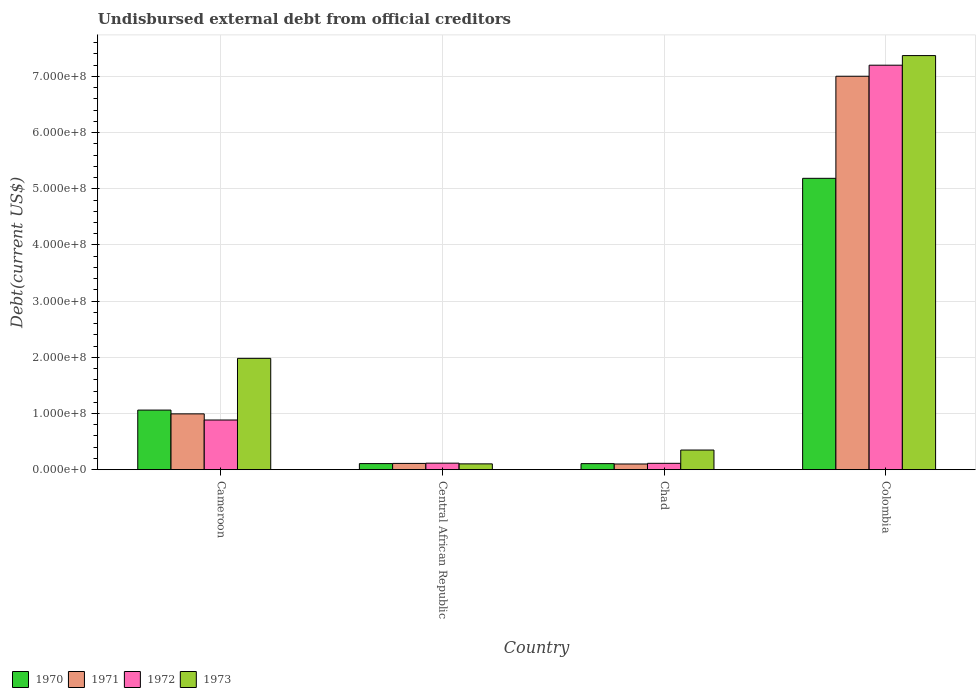How many groups of bars are there?
Your response must be concise. 4. Are the number of bars on each tick of the X-axis equal?
Offer a terse response. Yes. What is the label of the 2nd group of bars from the left?
Ensure brevity in your answer.  Central African Republic. In how many cases, is the number of bars for a given country not equal to the number of legend labels?
Provide a short and direct response. 0. What is the total debt in 1973 in Chad?
Ensure brevity in your answer.  3.50e+07. Across all countries, what is the maximum total debt in 1971?
Ensure brevity in your answer.  7.00e+08. Across all countries, what is the minimum total debt in 1973?
Make the answer very short. 1.04e+07. In which country was the total debt in 1970 maximum?
Make the answer very short. Colombia. In which country was the total debt in 1971 minimum?
Provide a succinct answer. Chad. What is the total total debt in 1970 in the graph?
Your answer should be very brief. 6.46e+08. What is the difference between the total debt in 1970 in Cameroon and that in Colombia?
Make the answer very short. -4.12e+08. What is the difference between the total debt in 1973 in Central African Republic and the total debt in 1972 in Cameroon?
Your answer should be compact. -7.81e+07. What is the average total debt in 1973 per country?
Make the answer very short. 2.45e+08. What is the difference between the total debt of/in 1972 and total debt of/in 1973 in Central African Republic?
Offer a terse response. 1.27e+06. In how many countries, is the total debt in 1972 greater than 360000000 US$?
Offer a terse response. 1. What is the ratio of the total debt in 1972 in Central African Republic to that in Colombia?
Give a very brief answer. 0.02. What is the difference between the highest and the second highest total debt in 1973?
Make the answer very short. 5.39e+08. What is the difference between the highest and the lowest total debt in 1973?
Ensure brevity in your answer.  7.27e+08. Is the sum of the total debt in 1973 in Chad and Colombia greater than the maximum total debt in 1970 across all countries?
Keep it short and to the point. Yes. What does the 3rd bar from the left in Central African Republic represents?
Make the answer very short. 1972. What does the 4th bar from the right in Cameroon represents?
Provide a short and direct response. 1970. Are all the bars in the graph horizontal?
Provide a succinct answer. No. Does the graph contain any zero values?
Provide a short and direct response. No. Does the graph contain grids?
Offer a terse response. Yes. Where does the legend appear in the graph?
Provide a succinct answer. Bottom left. What is the title of the graph?
Keep it short and to the point. Undisbursed external debt from official creditors. What is the label or title of the X-axis?
Make the answer very short. Country. What is the label or title of the Y-axis?
Your answer should be very brief. Debt(current US$). What is the Debt(current US$) in 1970 in Cameroon?
Provide a short and direct response. 1.06e+08. What is the Debt(current US$) in 1971 in Cameroon?
Your answer should be compact. 9.94e+07. What is the Debt(current US$) in 1972 in Cameroon?
Provide a short and direct response. 8.84e+07. What is the Debt(current US$) in 1973 in Cameroon?
Provide a succinct answer. 1.98e+08. What is the Debt(current US$) in 1970 in Central African Republic?
Offer a very short reply. 1.08e+07. What is the Debt(current US$) of 1971 in Central African Republic?
Your answer should be compact. 1.12e+07. What is the Debt(current US$) in 1972 in Central African Republic?
Offer a very short reply. 1.16e+07. What is the Debt(current US$) in 1973 in Central African Republic?
Offer a very short reply. 1.04e+07. What is the Debt(current US$) in 1970 in Chad?
Your response must be concise. 1.08e+07. What is the Debt(current US$) in 1971 in Chad?
Offer a terse response. 1.02e+07. What is the Debt(current US$) in 1972 in Chad?
Make the answer very short. 1.14e+07. What is the Debt(current US$) of 1973 in Chad?
Your answer should be compact. 3.50e+07. What is the Debt(current US$) in 1970 in Colombia?
Provide a succinct answer. 5.19e+08. What is the Debt(current US$) in 1971 in Colombia?
Your answer should be very brief. 7.00e+08. What is the Debt(current US$) in 1972 in Colombia?
Ensure brevity in your answer.  7.20e+08. What is the Debt(current US$) of 1973 in Colombia?
Provide a short and direct response. 7.37e+08. Across all countries, what is the maximum Debt(current US$) in 1970?
Provide a succinct answer. 5.19e+08. Across all countries, what is the maximum Debt(current US$) in 1971?
Provide a short and direct response. 7.00e+08. Across all countries, what is the maximum Debt(current US$) of 1972?
Your response must be concise. 7.20e+08. Across all countries, what is the maximum Debt(current US$) of 1973?
Keep it short and to the point. 7.37e+08. Across all countries, what is the minimum Debt(current US$) of 1970?
Make the answer very short. 1.08e+07. Across all countries, what is the minimum Debt(current US$) of 1971?
Offer a terse response. 1.02e+07. Across all countries, what is the minimum Debt(current US$) in 1972?
Ensure brevity in your answer.  1.14e+07. Across all countries, what is the minimum Debt(current US$) of 1973?
Provide a short and direct response. 1.04e+07. What is the total Debt(current US$) in 1970 in the graph?
Make the answer very short. 6.46e+08. What is the total Debt(current US$) of 1971 in the graph?
Make the answer very short. 8.21e+08. What is the total Debt(current US$) of 1972 in the graph?
Give a very brief answer. 8.31e+08. What is the total Debt(current US$) in 1973 in the graph?
Offer a very short reply. 9.81e+08. What is the difference between the Debt(current US$) of 1970 in Cameroon and that in Central African Republic?
Your response must be concise. 9.52e+07. What is the difference between the Debt(current US$) in 1971 in Cameroon and that in Central African Republic?
Ensure brevity in your answer.  8.82e+07. What is the difference between the Debt(current US$) in 1972 in Cameroon and that in Central African Republic?
Offer a very short reply. 7.68e+07. What is the difference between the Debt(current US$) in 1973 in Cameroon and that in Central African Republic?
Offer a very short reply. 1.88e+08. What is the difference between the Debt(current US$) in 1970 in Cameroon and that in Chad?
Your answer should be compact. 9.53e+07. What is the difference between the Debt(current US$) of 1971 in Cameroon and that in Chad?
Your answer should be very brief. 8.92e+07. What is the difference between the Debt(current US$) in 1972 in Cameroon and that in Chad?
Offer a very short reply. 7.71e+07. What is the difference between the Debt(current US$) of 1973 in Cameroon and that in Chad?
Offer a very short reply. 1.63e+08. What is the difference between the Debt(current US$) in 1970 in Cameroon and that in Colombia?
Make the answer very short. -4.12e+08. What is the difference between the Debt(current US$) of 1971 in Cameroon and that in Colombia?
Your answer should be very brief. -6.01e+08. What is the difference between the Debt(current US$) of 1972 in Cameroon and that in Colombia?
Provide a succinct answer. -6.31e+08. What is the difference between the Debt(current US$) of 1973 in Cameroon and that in Colombia?
Make the answer very short. -5.39e+08. What is the difference between the Debt(current US$) in 1970 in Central African Republic and that in Chad?
Provide a succinct answer. 5.50e+04. What is the difference between the Debt(current US$) in 1971 in Central African Republic and that in Chad?
Keep it short and to the point. 1.04e+06. What is the difference between the Debt(current US$) in 1972 in Central African Republic and that in Chad?
Offer a very short reply. 2.79e+05. What is the difference between the Debt(current US$) in 1973 in Central African Republic and that in Chad?
Keep it short and to the point. -2.46e+07. What is the difference between the Debt(current US$) in 1970 in Central African Republic and that in Colombia?
Give a very brief answer. -5.08e+08. What is the difference between the Debt(current US$) of 1971 in Central African Republic and that in Colombia?
Offer a terse response. -6.89e+08. What is the difference between the Debt(current US$) of 1972 in Central African Republic and that in Colombia?
Your answer should be compact. -7.08e+08. What is the difference between the Debt(current US$) in 1973 in Central African Republic and that in Colombia?
Your response must be concise. -7.27e+08. What is the difference between the Debt(current US$) of 1970 in Chad and that in Colombia?
Ensure brevity in your answer.  -5.08e+08. What is the difference between the Debt(current US$) of 1971 in Chad and that in Colombia?
Your answer should be compact. -6.90e+08. What is the difference between the Debt(current US$) in 1972 in Chad and that in Colombia?
Provide a succinct answer. -7.09e+08. What is the difference between the Debt(current US$) of 1973 in Chad and that in Colombia?
Make the answer very short. -7.02e+08. What is the difference between the Debt(current US$) of 1970 in Cameroon and the Debt(current US$) of 1971 in Central African Republic?
Keep it short and to the point. 9.49e+07. What is the difference between the Debt(current US$) of 1970 in Cameroon and the Debt(current US$) of 1972 in Central African Republic?
Ensure brevity in your answer.  9.45e+07. What is the difference between the Debt(current US$) in 1970 in Cameroon and the Debt(current US$) in 1973 in Central African Republic?
Provide a short and direct response. 9.57e+07. What is the difference between the Debt(current US$) of 1971 in Cameroon and the Debt(current US$) of 1972 in Central African Republic?
Your response must be concise. 8.77e+07. What is the difference between the Debt(current US$) of 1971 in Cameroon and the Debt(current US$) of 1973 in Central African Republic?
Make the answer very short. 8.90e+07. What is the difference between the Debt(current US$) in 1972 in Cameroon and the Debt(current US$) in 1973 in Central African Republic?
Provide a short and direct response. 7.81e+07. What is the difference between the Debt(current US$) of 1970 in Cameroon and the Debt(current US$) of 1971 in Chad?
Offer a very short reply. 9.59e+07. What is the difference between the Debt(current US$) of 1970 in Cameroon and the Debt(current US$) of 1972 in Chad?
Ensure brevity in your answer.  9.47e+07. What is the difference between the Debt(current US$) of 1970 in Cameroon and the Debt(current US$) of 1973 in Chad?
Offer a terse response. 7.11e+07. What is the difference between the Debt(current US$) in 1971 in Cameroon and the Debt(current US$) in 1972 in Chad?
Keep it short and to the point. 8.80e+07. What is the difference between the Debt(current US$) of 1971 in Cameroon and the Debt(current US$) of 1973 in Chad?
Make the answer very short. 6.44e+07. What is the difference between the Debt(current US$) of 1972 in Cameroon and the Debt(current US$) of 1973 in Chad?
Your answer should be very brief. 5.35e+07. What is the difference between the Debt(current US$) in 1970 in Cameroon and the Debt(current US$) in 1971 in Colombia?
Keep it short and to the point. -5.94e+08. What is the difference between the Debt(current US$) of 1970 in Cameroon and the Debt(current US$) of 1972 in Colombia?
Your answer should be very brief. -6.14e+08. What is the difference between the Debt(current US$) in 1970 in Cameroon and the Debt(current US$) in 1973 in Colombia?
Your response must be concise. -6.31e+08. What is the difference between the Debt(current US$) of 1971 in Cameroon and the Debt(current US$) of 1972 in Colombia?
Keep it short and to the point. -6.21e+08. What is the difference between the Debt(current US$) in 1971 in Cameroon and the Debt(current US$) in 1973 in Colombia?
Keep it short and to the point. -6.38e+08. What is the difference between the Debt(current US$) of 1972 in Cameroon and the Debt(current US$) of 1973 in Colombia?
Provide a short and direct response. -6.49e+08. What is the difference between the Debt(current US$) of 1970 in Central African Republic and the Debt(current US$) of 1971 in Chad?
Make the answer very short. 6.94e+05. What is the difference between the Debt(current US$) in 1970 in Central African Republic and the Debt(current US$) in 1972 in Chad?
Offer a terse response. -5.09e+05. What is the difference between the Debt(current US$) of 1970 in Central African Republic and the Debt(current US$) of 1973 in Chad?
Provide a short and direct response. -2.41e+07. What is the difference between the Debt(current US$) of 1971 in Central African Republic and the Debt(current US$) of 1972 in Chad?
Give a very brief answer. -1.65e+05. What is the difference between the Debt(current US$) in 1971 in Central African Republic and the Debt(current US$) in 1973 in Chad?
Your response must be concise. -2.38e+07. What is the difference between the Debt(current US$) in 1972 in Central African Republic and the Debt(current US$) in 1973 in Chad?
Your answer should be very brief. -2.34e+07. What is the difference between the Debt(current US$) of 1970 in Central African Republic and the Debt(current US$) of 1971 in Colombia?
Provide a short and direct response. -6.89e+08. What is the difference between the Debt(current US$) in 1970 in Central African Republic and the Debt(current US$) in 1972 in Colombia?
Offer a terse response. -7.09e+08. What is the difference between the Debt(current US$) in 1970 in Central African Republic and the Debt(current US$) in 1973 in Colombia?
Offer a very short reply. -7.26e+08. What is the difference between the Debt(current US$) in 1971 in Central African Republic and the Debt(current US$) in 1972 in Colombia?
Your response must be concise. -7.09e+08. What is the difference between the Debt(current US$) in 1971 in Central African Republic and the Debt(current US$) in 1973 in Colombia?
Give a very brief answer. -7.26e+08. What is the difference between the Debt(current US$) in 1972 in Central African Republic and the Debt(current US$) in 1973 in Colombia?
Provide a succinct answer. -7.25e+08. What is the difference between the Debt(current US$) in 1970 in Chad and the Debt(current US$) in 1971 in Colombia?
Your answer should be very brief. -6.89e+08. What is the difference between the Debt(current US$) of 1970 in Chad and the Debt(current US$) of 1972 in Colombia?
Make the answer very short. -7.09e+08. What is the difference between the Debt(current US$) in 1970 in Chad and the Debt(current US$) in 1973 in Colombia?
Offer a terse response. -7.26e+08. What is the difference between the Debt(current US$) of 1971 in Chad and the Debt(current US$) of 1972 in Colombia?
Provide a short and direct response. -7.10e+08. What is the difference between the Debt(current US$) of 1971 in Chad and the Debt(current US$) of 1973 in Colombia?
Offer a terse response. -7.27e+08. What is the difference between the Debt(current US$) of 1972 in Chad and the Debt(current US$) of 1973 in Colombia?
Provide a succinct answer. -7.26e+08. What is the average Debt(current US$) of 1970 per country?
Provide a succinct answer. 1.62e+08. What is the average Debt(current US$) in 1971 per country?
Ensure brevity in your answer.  2.05e+08. What is the average Debt(current US$) in 1972 per country?
Ensure brevity in your answer.  2.08e+08. What is the average Debt(current US$) in 1973 per country?
Your answer should be compact. 2.45e+08. What is the difference between the Debt(current US$) of 1970 and Debt(current US$) of 1971 in Cameroon?
Give a very brief answer. 6.72e+06. What is the difference between the Debt(current US$) of 1970 and Debt(current US$) of 1972 in Cameroon?
Offer a very short reply. 1.76e+07. What is the difference between the Debt(current US$) in 1970 and Debt(current US$) in 1973 in Cameroon?
Provide a short and direct response. -9.21e+07. What is the difference between the Debt(current US$) in 1971 and Debt(current US$) in 1972 in Cameroon?
Offer a very short reply. 1.09e+07. What is the difference between the Debt(current US$) in 1971 and Debt(current US$) in 1973 in Cameroon?
Provide a short and direct response. -9.88e+07. What is the difference between the Debt(current US$) in 1972 and Debt(current US$) in 1973 in Cameroon?
Make the answer very short. -1.10e+08. What is the difference between the Debt(current US$) of 1970 and Debt(current US$) of 1971 in Central African Republic?
Offer a terse response. -3.44e+05. What is the difference between the Debt(current US$) in 1970 and Debt(current US$) in 1972 in Central African Republic?
Offer a very short reply. -7.88e+05. What is the difference between the Debt(current US$) in 1970 and Debt(current US$) in 1973 in Central African Republic?
Give a very brief answer. 4.80e+05. What is the difference between the Debt(current US$) of 1971 and Debt(current US$) of 1972 in Central African Republic?
Offer a terse response. -4.44e+05. What is the difference between the Debt(current US$) in 1971 and Debt(current US$) in 1973 in Central African Republic?
Your response must be concise. 8.24e+05. What is the difference between the Debt(current US$) in 1972 and Debt(current US$) in 1973 in Central African Republic?
Keep it short and to the point. 1.27e+06. What is the difference between the Debt(current US$) in 1970 and Debt(current US$) in 1971 in Chad?
Ensure brevity in your answer.  6.39e+05. What is the difference between the Debt(current US$) in 1970 and Debt(current US$) in 1972 in Chad?
Offer a terse response. -5.64e+05. What is the difference between the Debt(current US$) in 1970 and Debt(current US$) in 1973 in Chad?
Offer a very short reply. -2.42e+07. What is the difference between the Debt(current US$) of 1971 and Debt(current US$) of 1972 in Chad?
Make the answer very short. -1.20e+06. What is the difference between the Debt(current US$) of 1971 and Debt(current US$) of 1973 in Chad?
Offer a terse response. -2.48e+07. What is the difference between the Debt(current US$) in 1972 and Debt(current US$) in 1973 in Chad?
Your response must be concise. -2.36e+07. What is the difference between the Debt(current US$) in 1970 and Debt(current US$) in 1971 in Colombia?
Provide a short and direct response. -1.82e+08. What is the difference between the Debt(current US$) of 1970 and Debt(current US$) of 1972 in Colombia?
Offer a very short reply. -2.01e+08. What is the difference between the Debt(current US$) in 1970 and Debt(current US$) in 1973 in Colombia?
Make the answer very short. -2.18e+08. What is the difference between the Debt(current US$) of 1971 and Debt(current US$) of 1972 in Colombia?
Your answer should be very brief. -1.97e+07. What is the difference between the Debt(current US$) of 1971 and Debt(current US$) of 1973 in Colombia?
Give a very brief answer. -3.68e+07. What is the difference between the Debt(current US$) in 1972 and Debt(current US$) in 1973 in Colombia?
Offer a terse response. -1.71e+07. What is the ratio of the Debt(current US$) of 1970 in Cameroon to that in Central African Republic?
Your response must be concise. 9.78. What is the ratio of the Debt(current US$) in 1971 in Cameroon to that in Central African Republic?
Your answer should be very brief. 8.88. What is the ratio of the Debt(current US$) of 1972 in Cameroon to that in Central African Republic?
Provide a succinct answer. 7.6. What is the ratio of the Debt(current US$) of 1973 in Cameroon to that in Central African Republic?
Offer a very short reply. 19.11. What is the ratio of the Debt(current US$) of 1970 in Cameroon to that in Chad?
Provide a succinct answer. 9.83. What is the ratio of the Debt(current US$) in 1971 in Cameroon to that in Chad?
Provide a succinct answer. 9.79. What is the ratio of the Debt(current US$) in 1972 in Cameroon to that in Chad?
Provide a short and direct response. 7.79. What is the ratio of the Debt(current US$) of 1973 in Cameroon to that in Chad?
Your response must be concise. 5.66. What is the ratio of the Debt(current US$) in 1970 in Cameroon to that in Colombia?
Offer a very short reply. 0.2. What is the ratio of the Debt(current US$) in 1971 in Cameroon to that in Colombia?
Your response must be concise. 0.14. What is the ratio of the Debt(current US$) in 1972 in Cameroon to that in Colombia?
Provide a succinct answer. 0.12. What is the ratio of the Debt(current US$) of 1973 in Cameroon to that in Colombia?
Provide a succinct answer. 0.27. What is the ratio of the Debt(current US$) in 1971 in Central African Republic to that in Chad?
Make the answer very short. 1.1. What is the ratio of the Debt(current US$) of 1972 in Central African Republic to that in Chad?
Offer a very short reply. 1.02. What is the ratio of the Debt(current US$) in 1973 in Central African Republic to that in Chad?
Your answer should be very brief. 0.3. What is the ratio of the Debt(current US$) of 1970 in Central African Republic to that in Colombia?
Keep it short and to the point. 0.02. What is the ratio of the Debt(current US$) in 1971 in Central African Republic to that in Colombia?
Make the answer very short. 0.02. What is the ratio of the Debt(current US$) in 1972 in Central African Republic to that in Colombia?
Offer a terse response. 0.02. What is the ratio of the Debt(current US$) in 1973 in Central African Republic to that in Colombia?
Your response must be concise. 0.01. What is the ratio of the Debt(current US$) in 1970 in Chad to that in Colombia?
Make the answer very short. 0.02. What is the ratio of the Debt(current US$) of 1971 in Chad to that in Colombia?
Make the answer very short. 0.01. What is the ratio of the Debt(current US$) in 1972 in Chad to that in Colombia?
Provide a short and direct response. 0.02. What is the ratio of the Debt(current US$) in 1973 in Chad to that in Colombia?
Provide a short and direct response. 0.05. What is the difference between the highest and the second highest Debt(current US$) of 1970?
Your response must be concise. 4.12e+08. What is the difference between the highest and the second highest Debt(current US$) of 1971?
Provide a short and direct response. 6.01e+08. What is the difference between the highest and the second highest Debt(current US$) of 1972?
Provide a succinct answer. 6.31e+08. What is the difference between the highest and the second highest Debt(current US$) of 1973?
Your answer should be very brief. 5.39e+08. What is the difference between the highest and the lowest Debt(current US$) of 1970?
Offer a terse response. 5.08e+08. What is the difference between the highest and the lowest Debt(current US$) of 1971?
Your response must be concise. 6.90e+08. What is the difference between the highest and the lowest Debt(current US$) in 1972?
Your answer should be very brief. 7.09e+08. What is the difference between the highest and the lowest Debt(current US$) of 1973?
Your answer should be compact. 7.27e+08. 